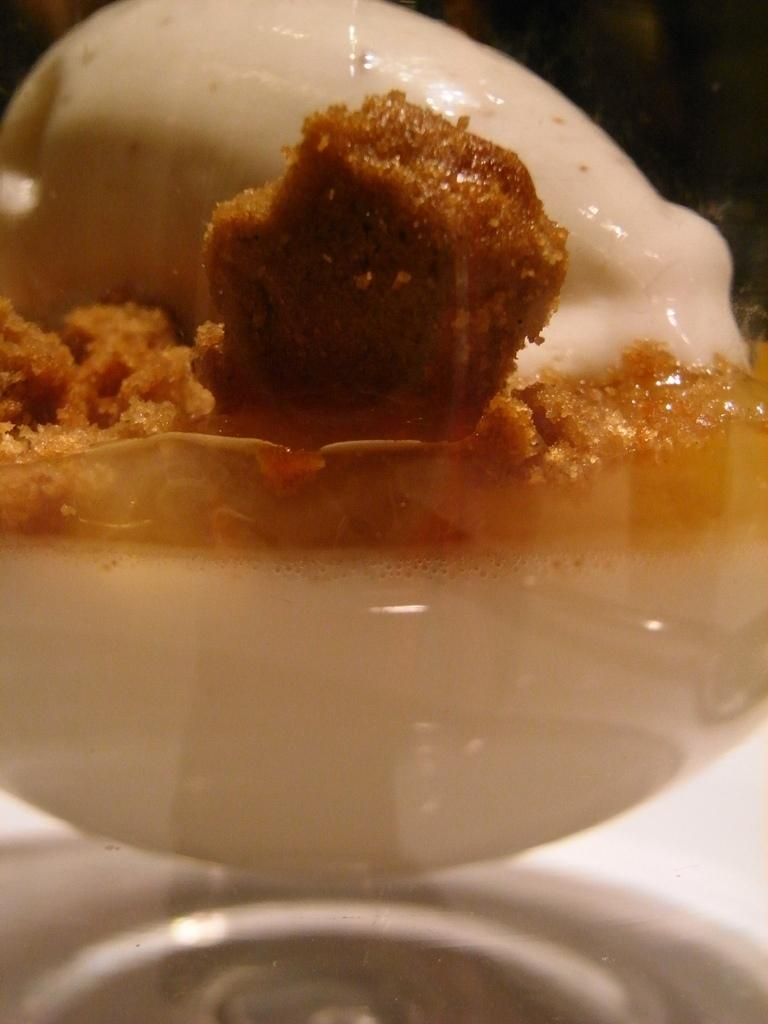What can be seen in the image? There is food in the image. What type of coal is being used to cook the food in the image? There is no coal or cooking process depicted in the image; it only shows food. How many times does the person in the image sneeze while preparing the food? There is no person or sneezing activity present in the image; it only shows food. 